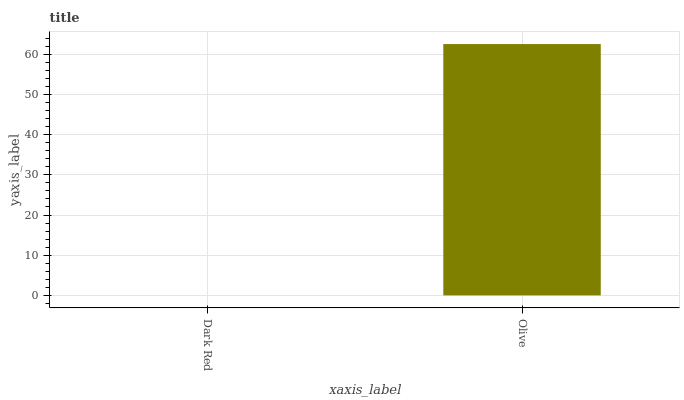Is Olive the minimum?
Answer yes or no. No. Is Olive greater than Dark Red?
Answer yes or no. Yes. Is Dark Red less than Olive?
Answer yes or no. Yes. Is Dark Red greater than Olive?
Answer yes or no. No. Is Olive less than Dark Red?
Answer yes or no. No. Is Olive the high median?
Answer yes or no. Yes. Is Dark Red the low median?
Answer yes or no. Yes. Is Dark Red the high median?
Answer yes or no. No. Is Olive the low median?
Answer yes or no. No. 